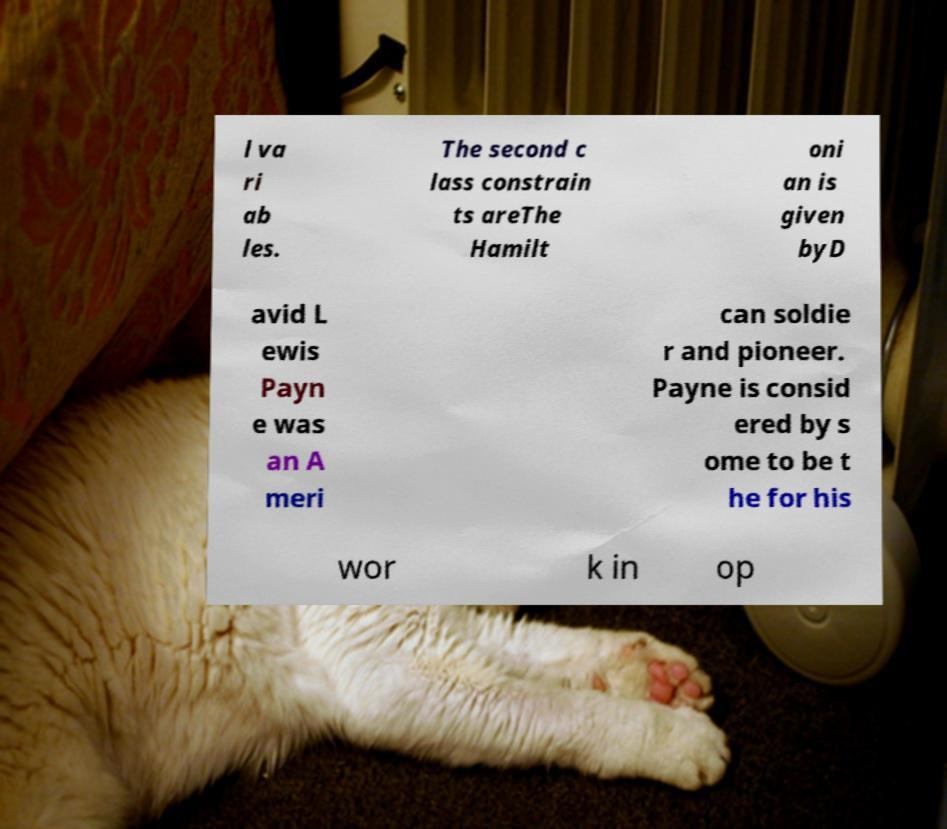Could you assist in decoding the text presented in this image and type it out clearly? l va ri ab les. The second c lass constrain ts areThe Hamilt oni an is given byD avid L ewis Payn e was an A meri can soldie r and pioneer. Payne is consid ered by s ome to be t he for his wor k in op 